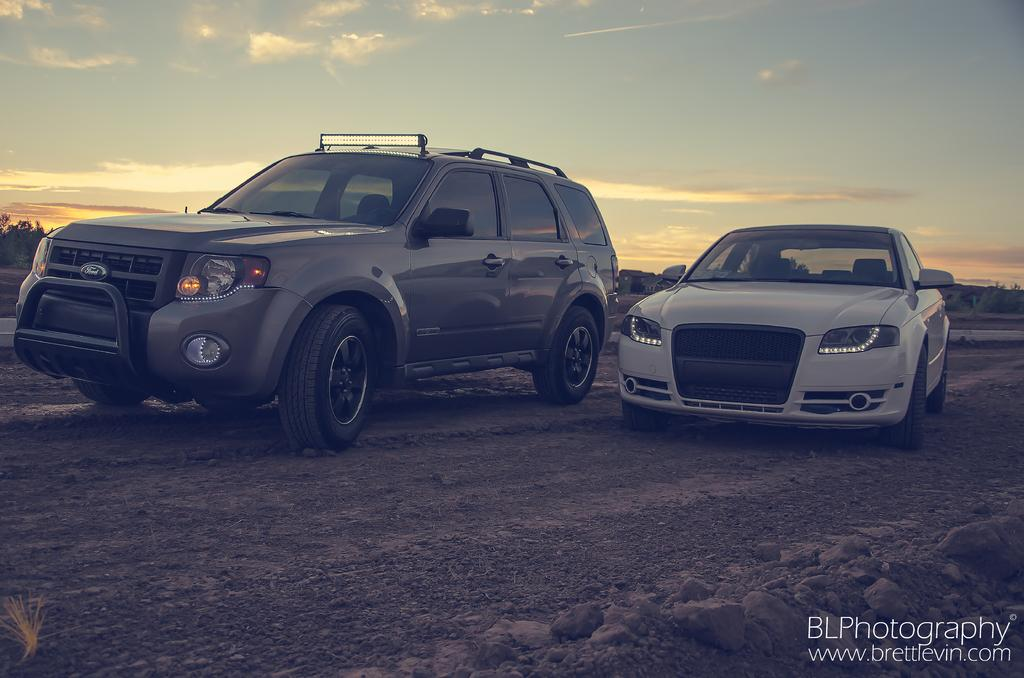What can be seen on the ground in the image? There are vehicles on the ground in the image. What is visible in the background of the image? There are trees and the sky in the background of the image. Is there any text or marking on the image? Yes, there is a watermark on the bottom right side of the image. What type of hope does the son have for his future in the image? There is no son or any reference to hope in the image; it features vehicles on the ground, trees and sky in the background, and a watermark on the bottom right side. 